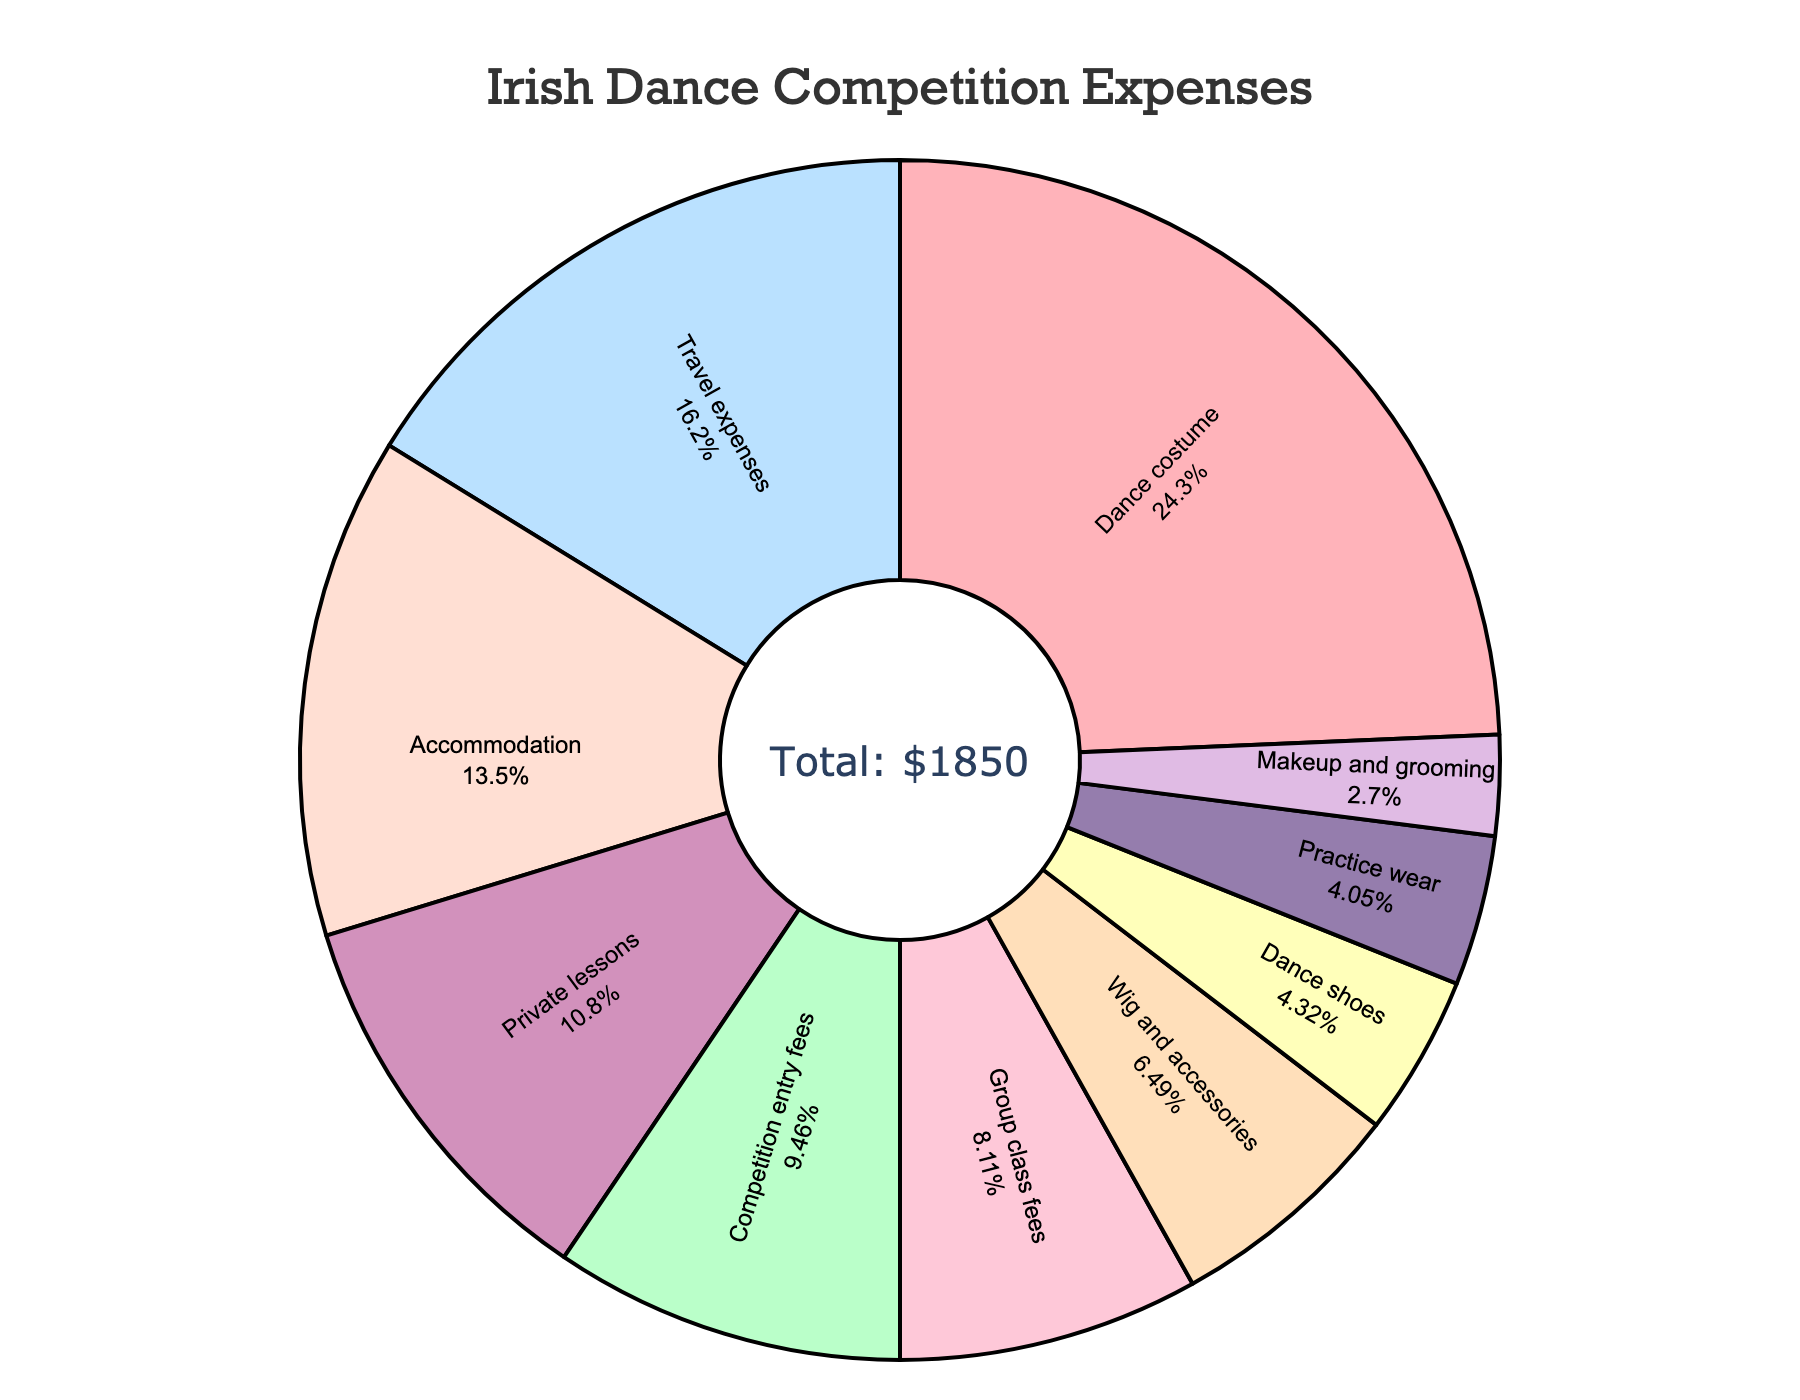Which category has the highest cost associated with it? The pie chart visually depicts that the "Dance costume" category occupies the largest portion of the chart, indicating it has the highest cost.
Answer: Dance costume What is the combined cost of travel expenses and accommodation? To find the combined cost, add the travel expenses of $300 and the accommodation cost of $250. $300 + $250 = $550
Answer: $550 How does the cost of private lessons compare to group class fees? The private lessons cost $200, while the group class fees are $150. Comparing the two, private lessons are more expensive by $50. $200 - $150 = $50
Answer: Private lessons are more expensive by $50 What percentage of the total cost is spent on competition entry fees? The pie chart shows the percentage values inside each section. For "Competition entry fees," it occupies 10% of the total chart.
Answer: 10% Which costs more: dance shoes or wig and accessories? By comparing the values from the chart, dance shoes cost $80 while wig and accessories cost $120. Therefore, wig and accessories cost more.
Answer: Wig and accessories Calculate the total cost of items used for appearance (Dance costume, Wig and accessories, Makeup and grooming). Sum up the costs of Dance costume ($450), Wig and accessories ($120), and Makeup and grooming ($50). $450 + $120 + $50 = $620
Answer: $620 What is the smallest cost category? The smallest section in the pie chart represents "Makeup and grooming," which has a cost of $50.
Answer: Makeup and grooming Which category comes second after dance costume in terms of costs? The second-largest section in the pie chart immediately following dance costume represents "Travel expenses," which is $300.
Answer: Travel expenses Is the total cost of practice wear and dance shoes greater than or less than $150? Add the cost of practice wear ($75) and dance shoes ($80). $75 + $80 = $155, which is greater than $150.
Answer: Greater than $150 What fraction of the total cost is attributed to private lessons? The cost of private lessons is $200 and the total cost is $1850. $200 / $1850 = 2/18.5 = 1/9.25 which simplifies approximately to 1/9.
Answer: 1/9 